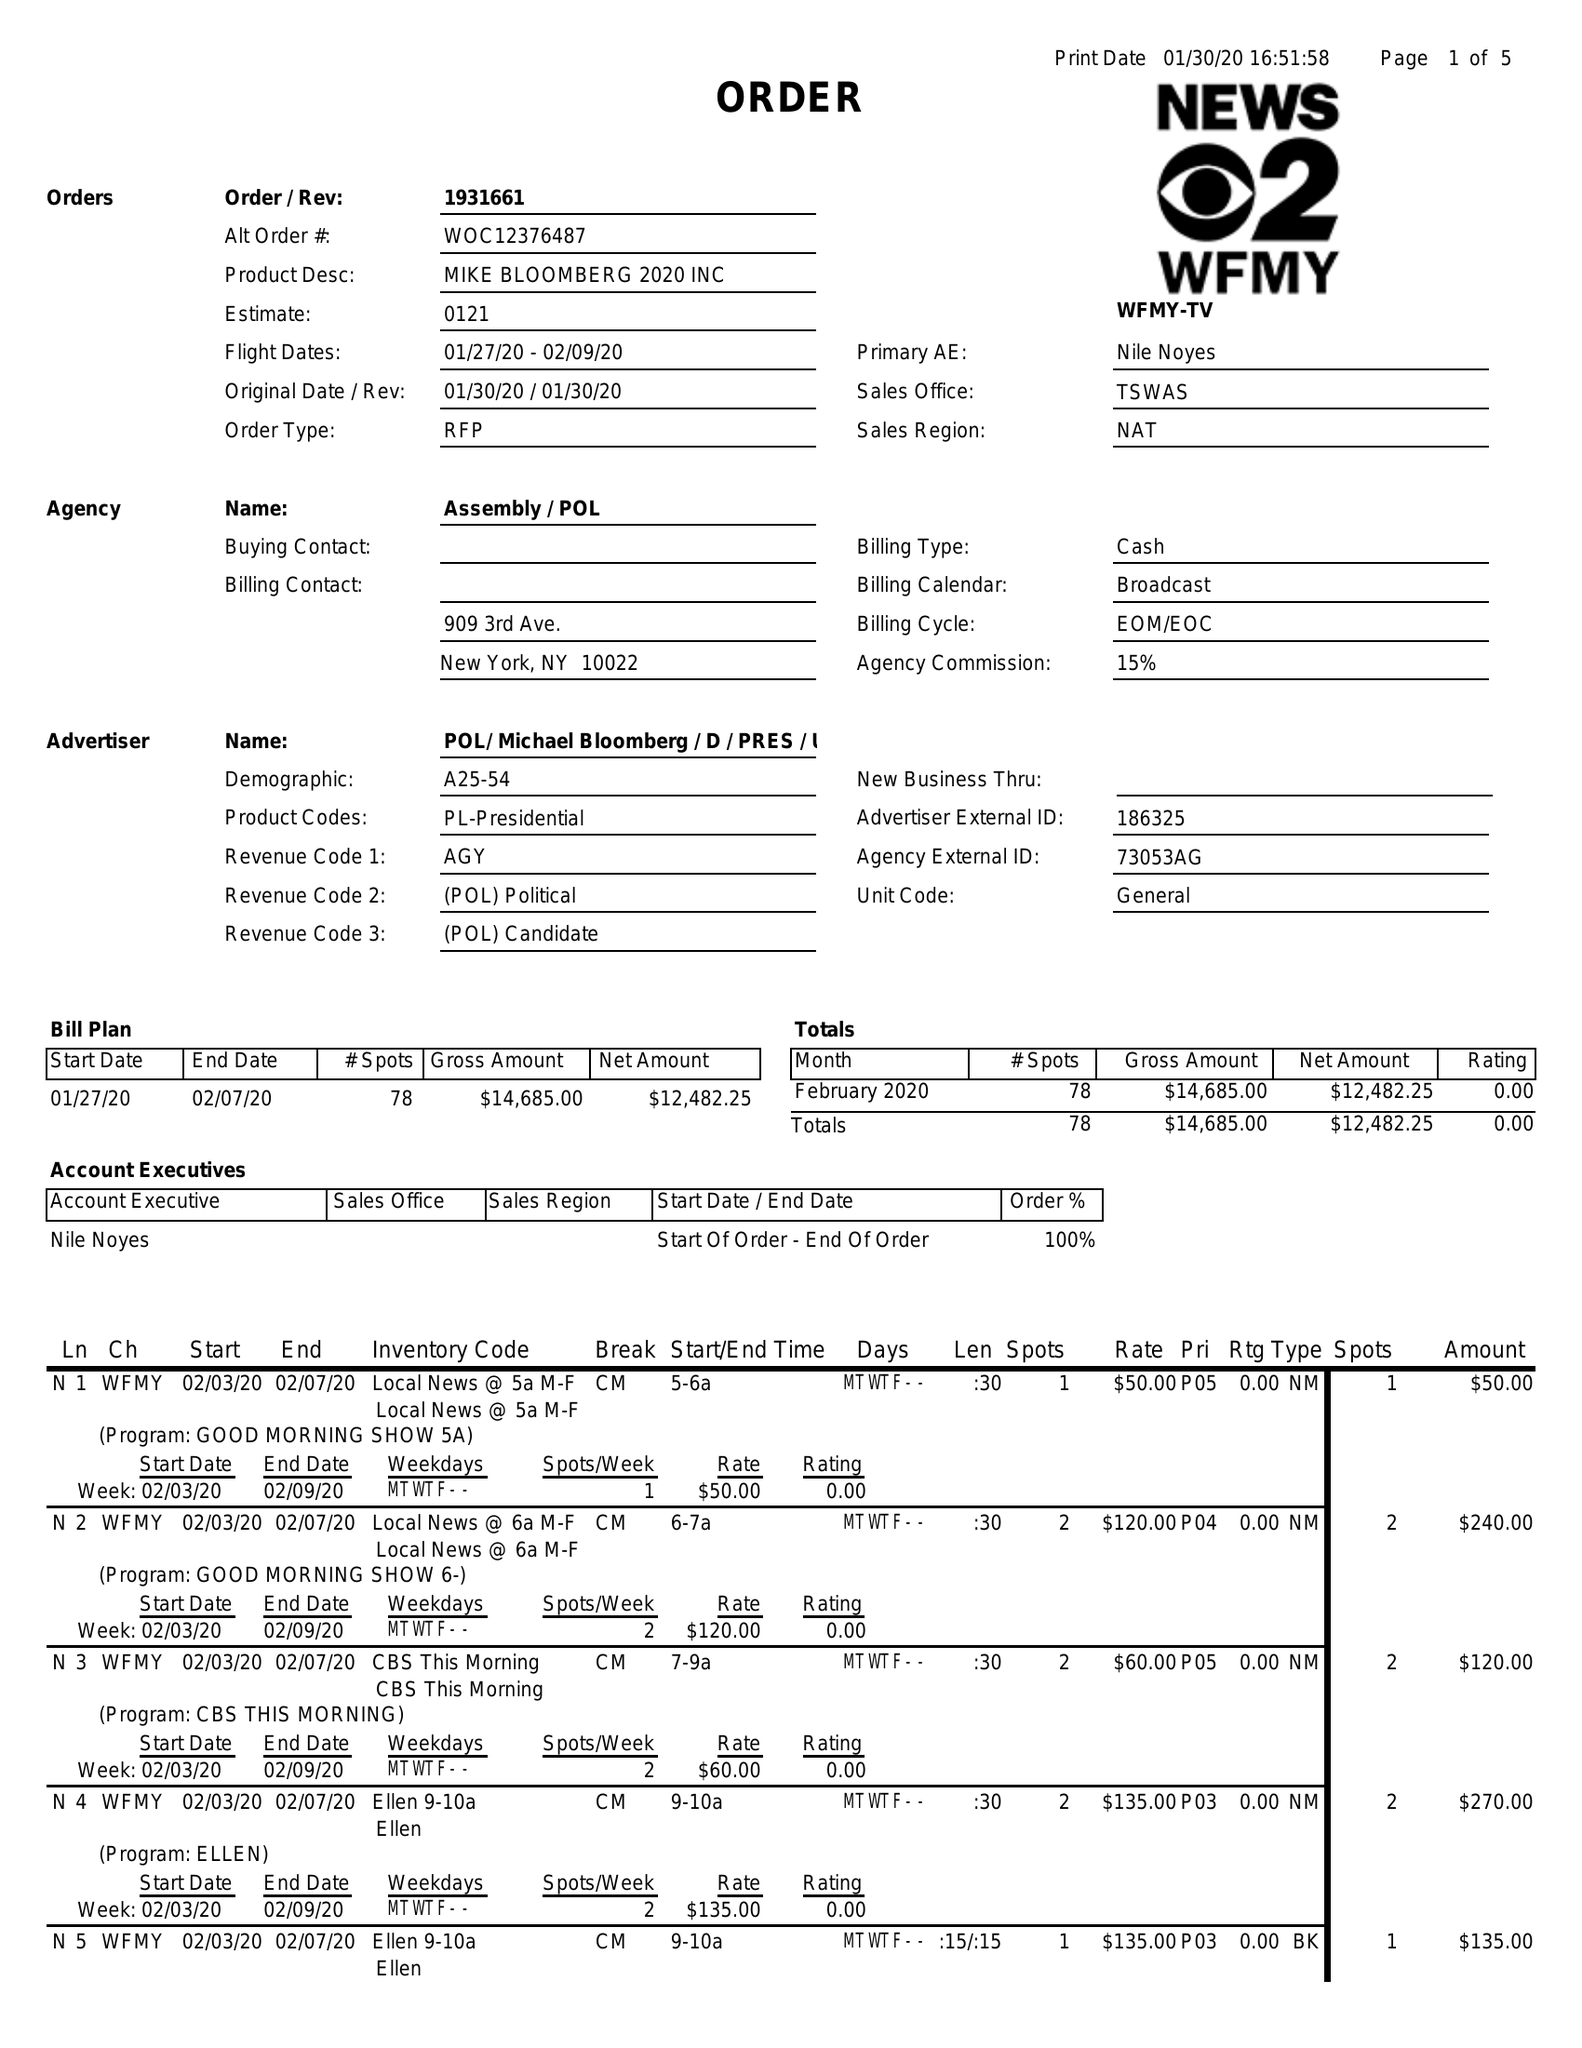What is the value for the gross_amount?
Answer the question using a single word or phrase. 14685.00 